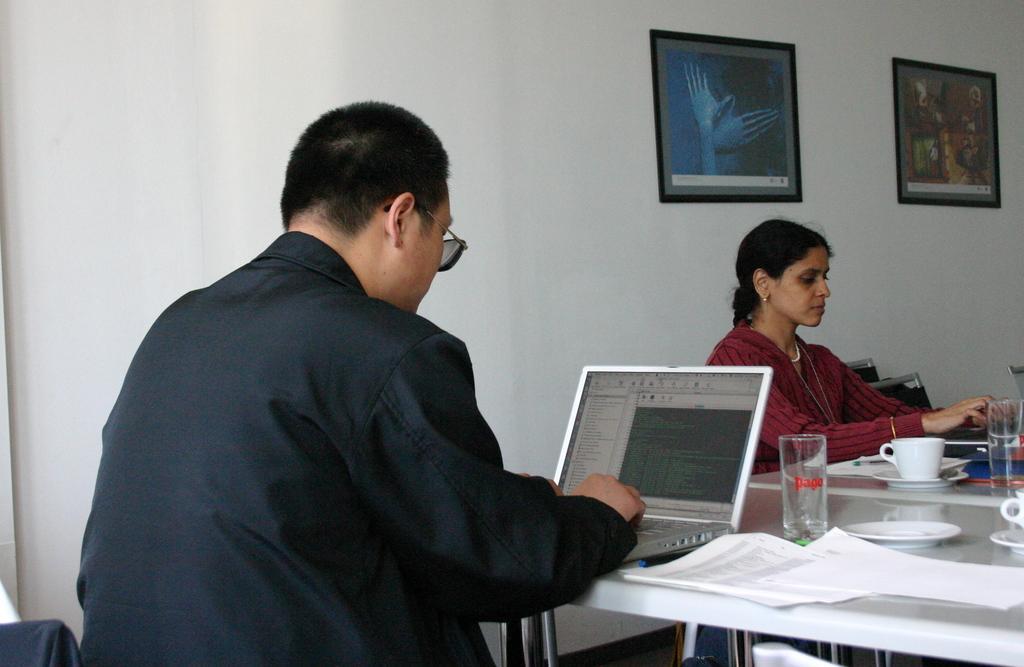Could you give a brief overview of what you see in this image? In the image it seems like there is a man who is working with the laptop which is kept on the table and beside the man there is another woman who is also working with the laptop. On the table there are cups,plates,papers and glass. At the background there is a wall and photo frame. 